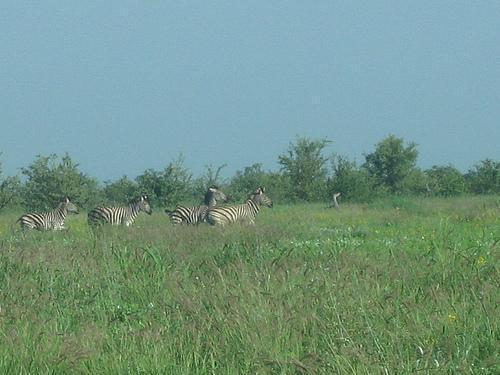How many zebras?
Give a very brief answer. 4. 